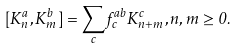<formula> <loc_0><loc_0><loc_500><loc_500>[ K _ { n } ^ { a } , K _ { m } ^ { b } ] = \sum _ { c } f _ { c } ^ { a b } K _ { n + m } ^ { c } , n , m \geq 0 .</formula> 